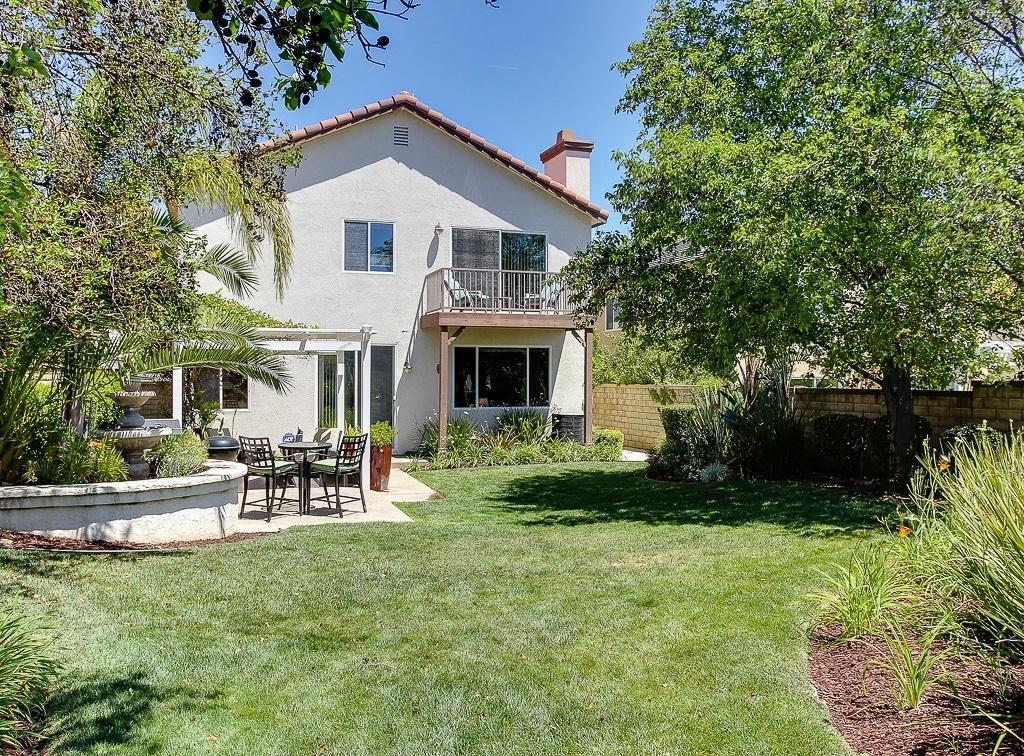In one or two sentences, can you explain what this image depicts? In this image we can see a building. In front of the building we can see the plants, grass, table and chairs. On the right side, we can see a wall, plants, trees and buildings. On the left side, we can see the fountain, plants and trees. At the top we can see the sky. 